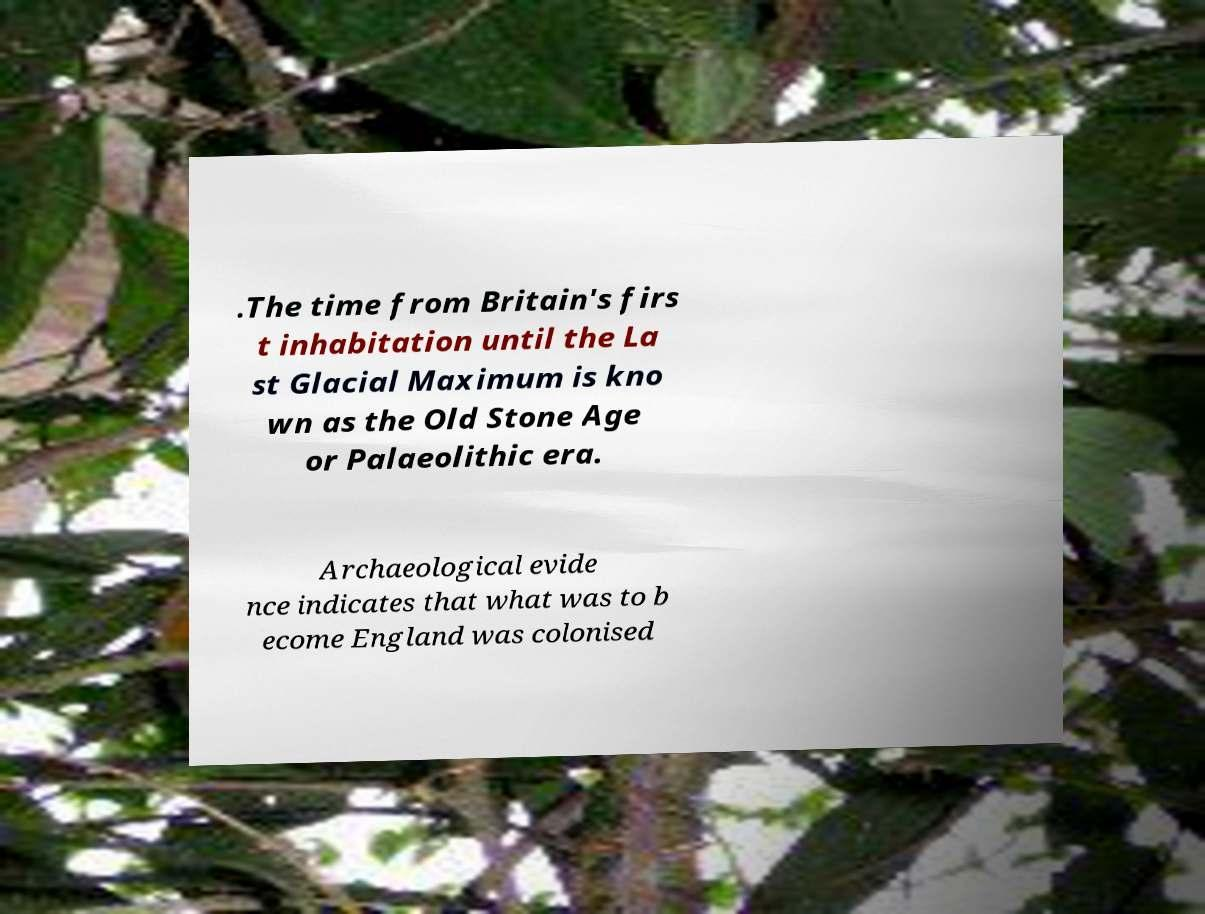Please read and relay the text visible in this image. What does it say? .The time from Britain's firs t inhabitation until the La st Glacial Maximum is kno wn as the Old Stone Age or Palaeolithic era. Archaeological evide nce indicates that what was to b ecome England was colonised 